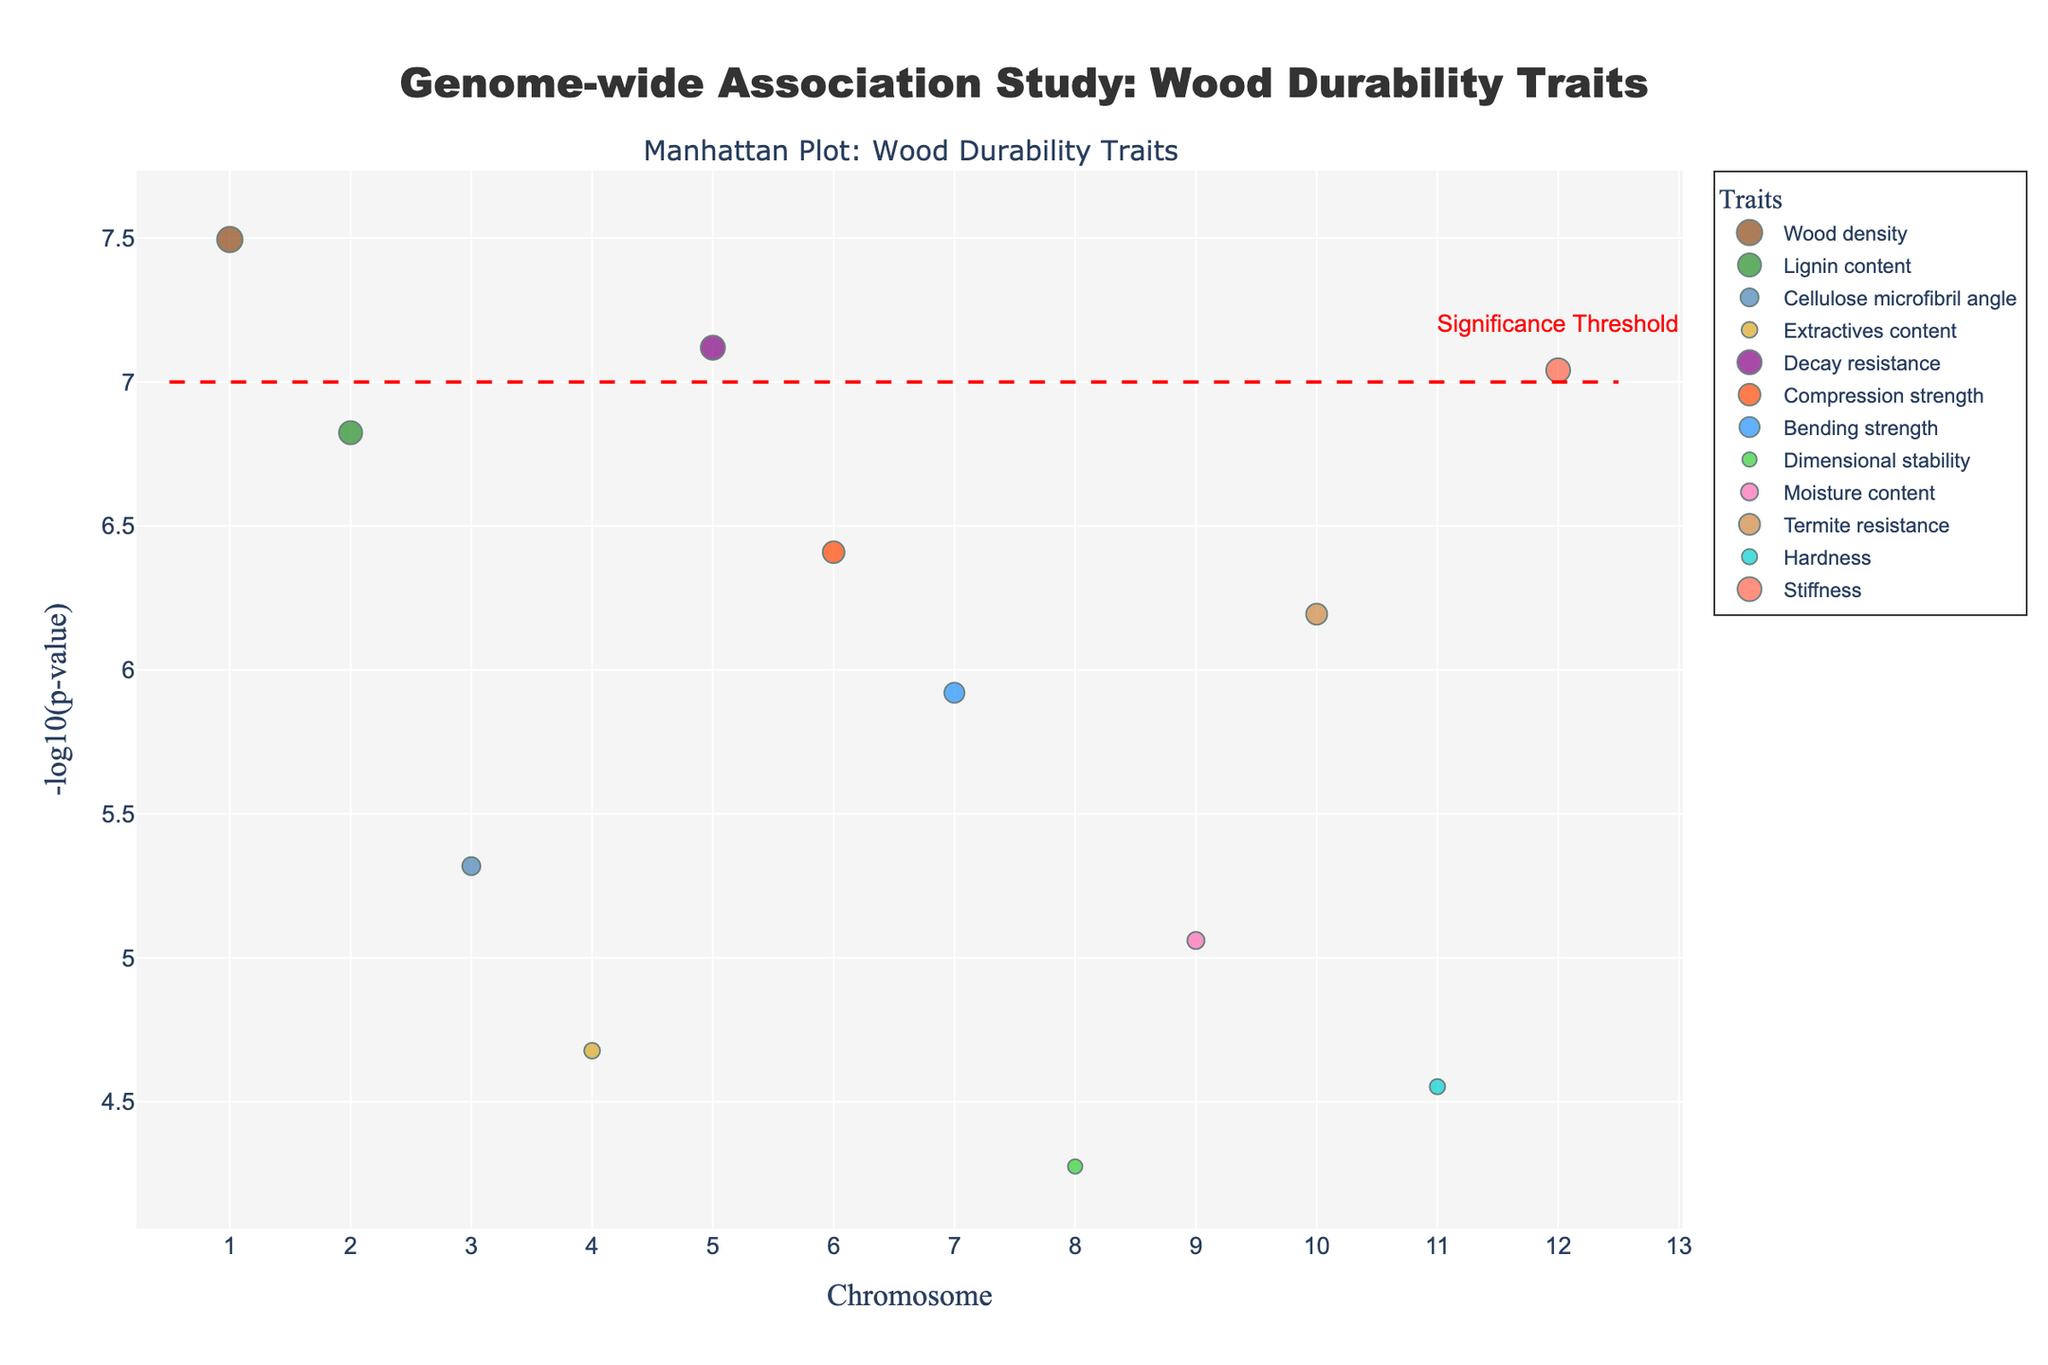What's the title of the plot? The title of the plot is shown prominently at the top of the figure, which reads "Genome-wide Association Study: Wood Durability Traits".
Answer: Genome-wide Association Study: Wood Durability Traits How many chromosomes are shown in the x-axis? The x-axis is labeled "Chromosome" and has tick marks for each chromosome from 1 to 12.
Answer: 12 Which trait has the highest -log10(p-value)? The trait with the highest y-value (which represents the -log10(p-value)) appears at chromosome 1 and is related to the trait "Wood Density".
Answer: Wood density What does the red dashed horizontal line represent? The red dashed horizontal line at y=7 is annotated with the text "Significance Threshold", indicating the level of statistical significance.
Answer: Significance Threshold Which gene is associated with the Lignin content trait? By examining the data points that are color-coded for the "Lignin content" trait, we see that the gene associated with this trait is CesA7 (at chromosome 2).
Answer: CesA7 How many traits exceed the significance threshold? Any point above the red dashed line (y=7) is statistically significant. Counting these points gives two data points (Wood density and Stiffness).
Answer: 2 Which chromosome has the data point with the largest marker size? By comparing the sizes of the markers visually, the largest marker appears on chromosome 5, which represents the trait "Decay resistance".
Answer: Chromosome 5 Among the genes CCR1 and COMT, which has a smaller p-value? Looking at the -log10(p-value) values, CCR1 (Chromosome 5, Decay resistance) has a -log10(p-value) higher than COMT (Chromosome 11, Hardness), indicating a smaller p-value.
Answer: CCR1 Which gene related to the "Bending strength" trait has the data point, and on what chromosome is it located? The Bending strength data point marked in a color-coded way is located at chromosome 7 and is associated with the gene CCoAOMT.
Answer: CCoAOMT on Chromosome 7 What is the range of the y-axis, and what measurement does it represent? The y-axis represents -log10(p-value) and ranges from 6 (below the significance threshold) to just over 8.
Answer: 6 to 8, -log10(p-value) 